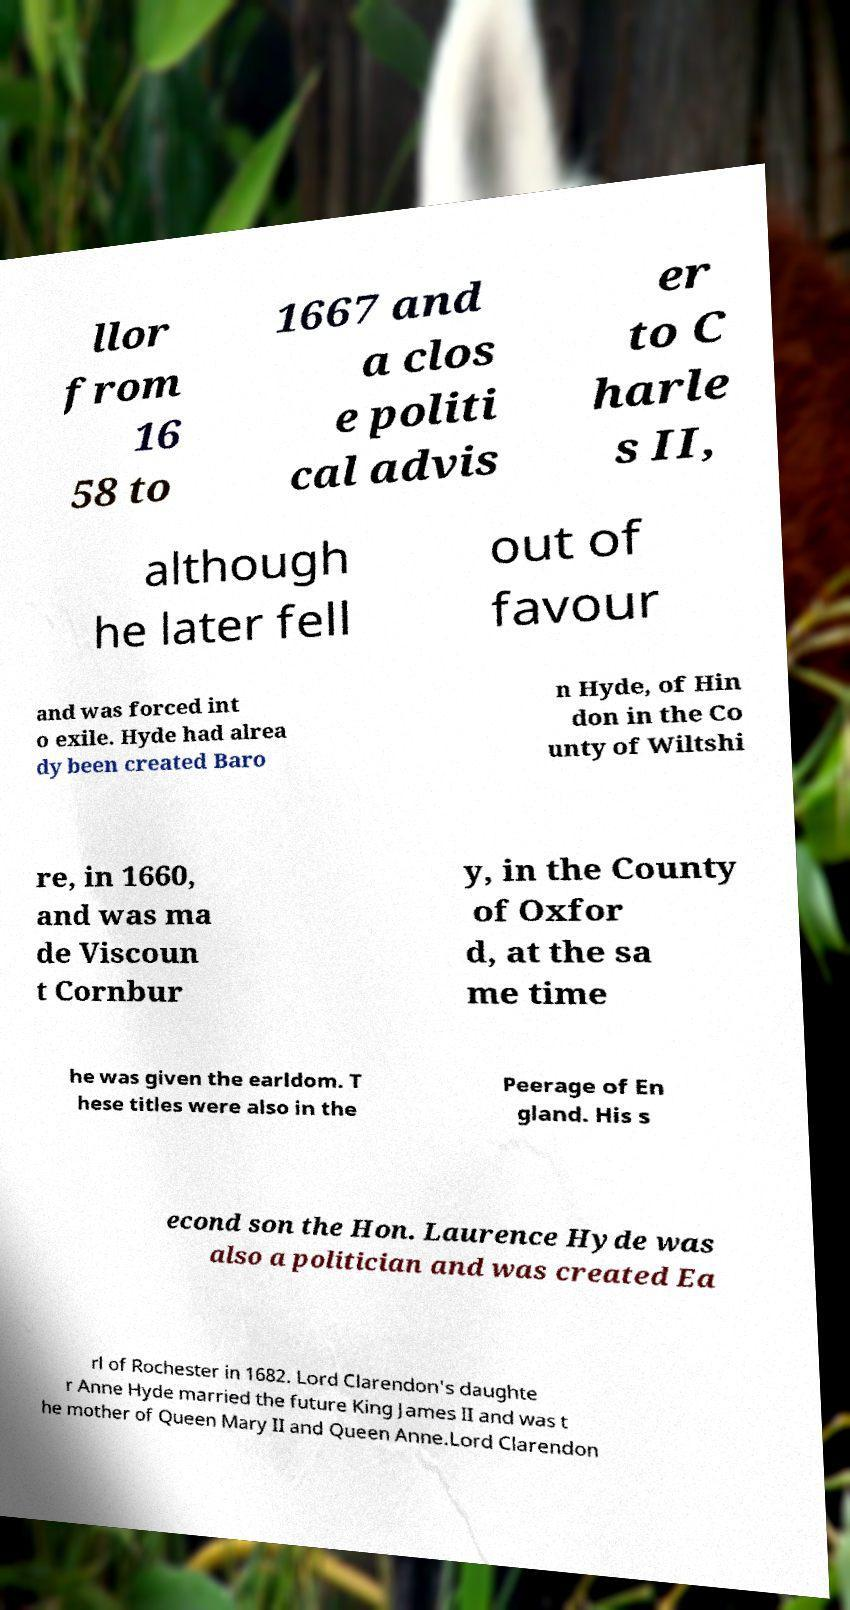Can you accurately transcribe the text from the provided image for me? llor from 16 58 to 1667 and a clos e politi cal advis er to C harle s II, although he later fell out of favour and was forced int o exile. Hyde had alrea dy been created Baro n Hyde, of Hin don in the Co unty of Wiltshi re, in 1660, and was ma de Viscoun t Cornbur y, in the County of Oxfor d, at the sa me time he was given the earldom. T hese titles were also in the Peerage of En gland. His s econd son the Hon. Laurence Hyde was also a politician and was created Ea rl of Rochester in 1682. Lord Clarendon's daughte r Anne Hyde married the future King James II and was t he mother of Queen Mary II and Queen Anne.Lord Clarendon 